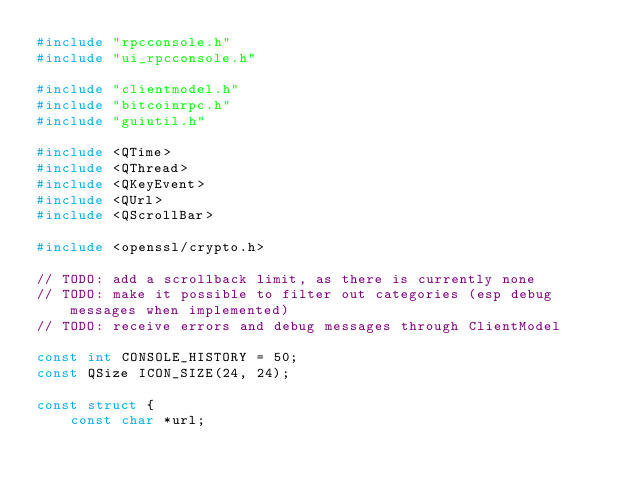<code> <loc_0><loc_0><loc_500><loc_500><_C++_>#include "rpcconsole.h"
#include "ui_rpcconsole.h"

#include "clientmodel.h"
#include "bitcoinrpc.h"
#include "guiutil.h"

#include <QTime>
#include <QThread>
#include <QKeyEvent>
#include <QUrl>
#include <QScrollBar>

#include <openssl/crypto.h>

// TODO: add a scrollback limit, as there is currently none
// TODO: make it possible to filter out categories (esp debug messages when implemented)
// TODO: receive errors and debug messages through ClientModel

const int CONSOLE_HISTORY = 50;
const QSize ICON_SIZE(24, 24);

const struct {
    const char *url;</code> 